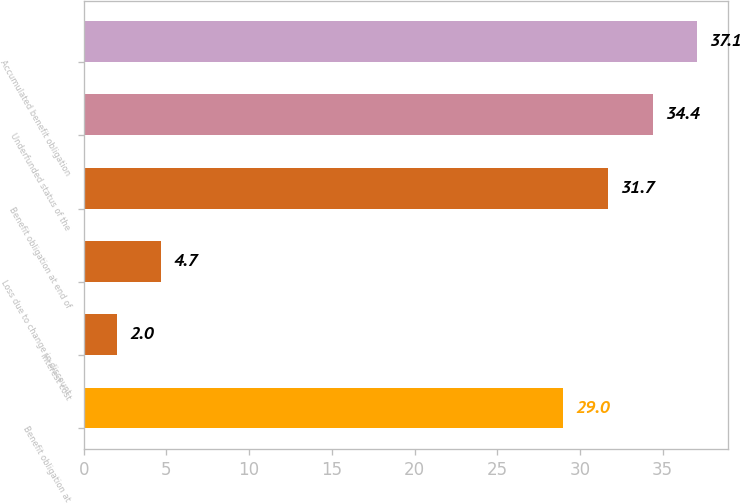<chart> <loc_0><loc_0><loc_500><loc_500><bar_chart><fcel>Benefit obligation at<fcel>Interest cost<fcel>Loss due to change in discount<fcel>Benefit obligation at end of<fcel>Underfunded status of the<fcel>Accumulated benefit obligation<nl><fcel>29<fcel>2<fcel>4.7<fcel>31.7<fcel>34.4<fcel>37.1<nl></chart> 